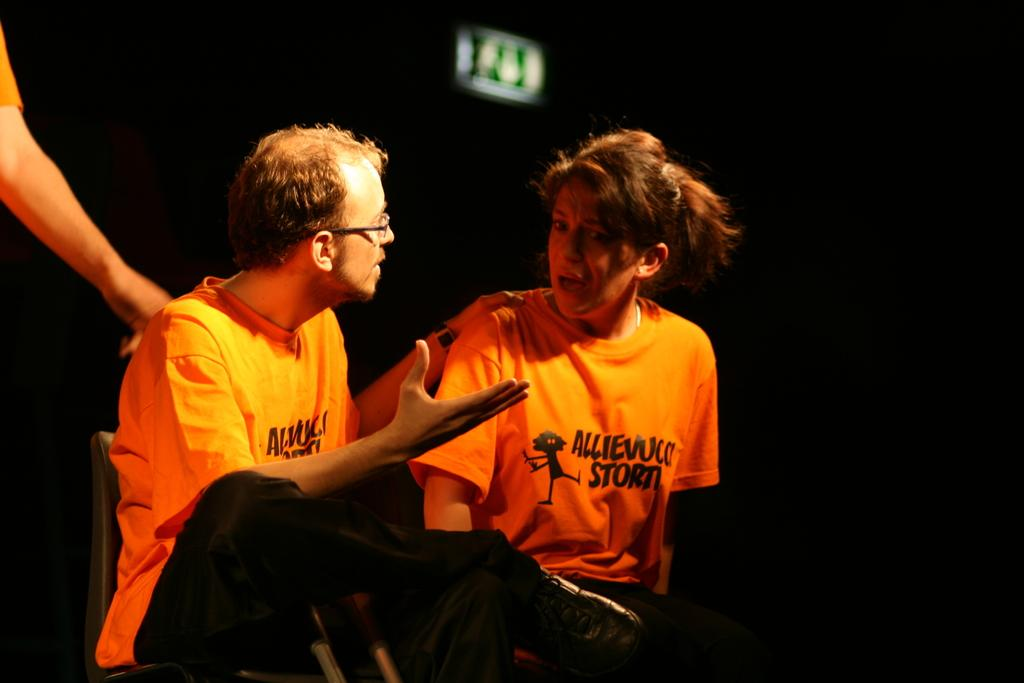How many persons are in the image? There are persons in the image. What can be observed about the background of the image? The background of the image is dark. What are the persons in the image wearing? The persons in the image are wearing clothes. What are the persons doing in the image? The persons are sitting on chairs. Can you describe any specific details about the persons' hands in the image? There is a person's hand visible in the top left of the image. What type of humor can be seen in the person's hand in the image? There is no humor present in the person's hand in the image. Is there a carpenter working on a mint plant in the image? There is no carpenter or mint plant present in the image. 